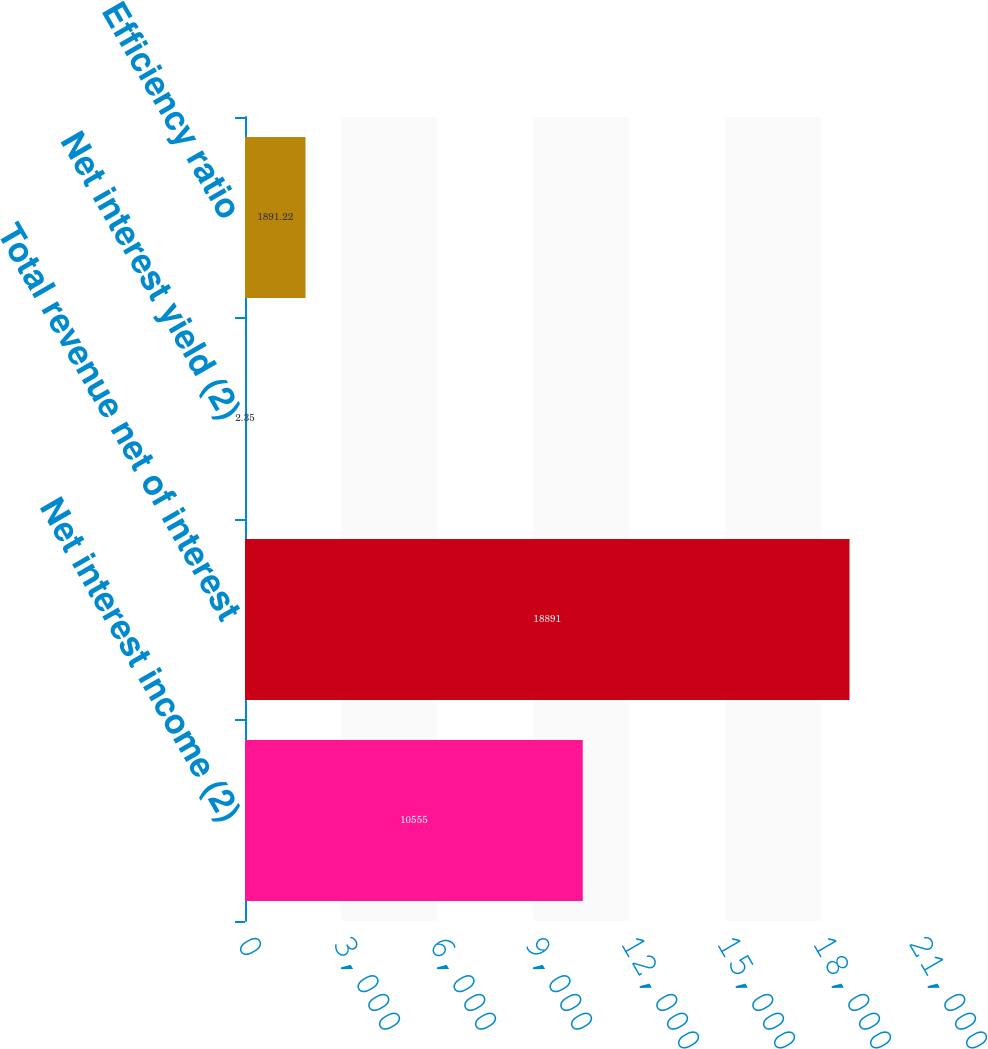Convert chart to OTSL. <chart><loc_0><loc_0><loc_500><loc_500><bar_chart><fcel>Net interest income (2)<fcel>Total revenue net of interest<fcel>Net interest yield (2)<fcel>Efficiency ratio<nl><fcel>10555<fcel>18891<fcel>2.35<fcel>1891.22<nl></chart> 